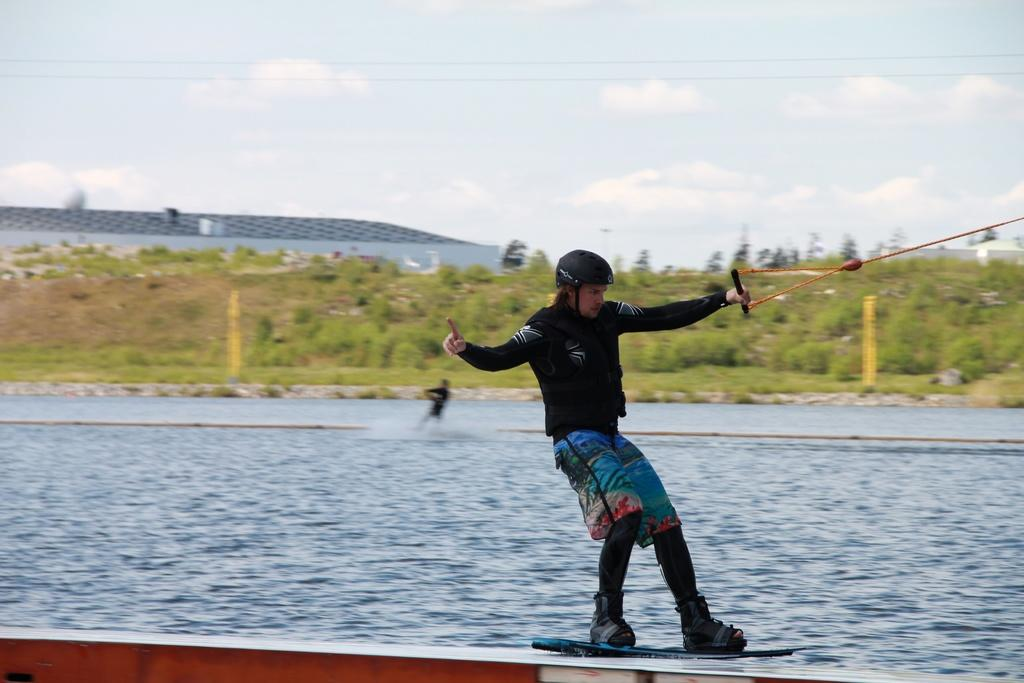How many people are in the image? There are two persons in the image. What activity are the persons engaged in? The persons are performing kitesurfing on the water. What can be seen in the background of the image? There are trees, buildings, and clouds in the background of the image. What is the credit score of the person kitesurfing on the left side of the image? There is no information about credit scores in the image, as it features people kitesurfing on the water with a background of trees, buildings, and clouds. 